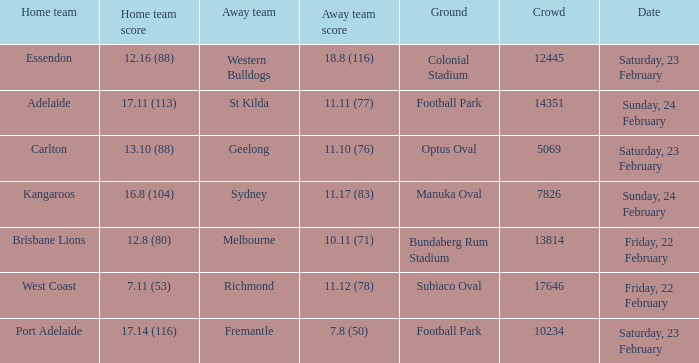On what date did the away team Fremantle play? Saturday, 23 February. 